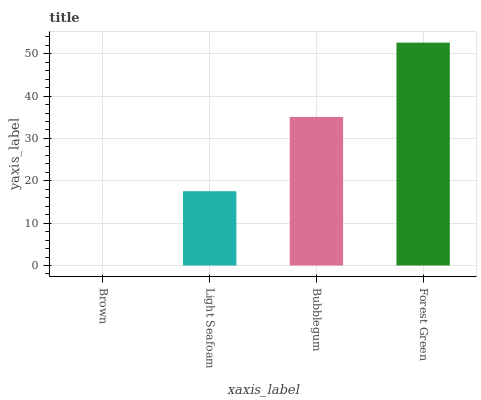Is Brown the minimum?
Answer yes or no. Yes. Is Forest Green the maximum?
Answer yes or no. Yes. Is Light Seafoam the minimum?
Answer yes or no. No. Is Light Seafoam the maximum?
Answer yes or no. No. Is Light Seafoam greater than Brown?
Answer yes or no. Yes. Is Brown less than Light Seafoam?
Answer yes or no. Yes. Is Brown greater than Light Seafoam?
Answer yes or no. No. Is Light Seafoam less than Brown?
Answer yes or no. No. Is Bubblegum the high median?
Answer yes or no. Yes. Is Light Seafoam the low median?
Answer yes or no. Yes. Is Forest Green the high median?
Answer yes or no. No. Is Brown the low median?
Answer yes or no. No. 